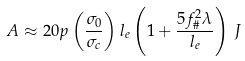Convert formula to latex. <formula><loc_0><loc_0><loc_500><loc_500>A \approx 2 0 p \left ( \frac { \sigma _ { 0 } } { \sigma _ { c } } \right ) l _ { e } \left ( 1 + \frac { 5 f _ { \# } ^ { 2 } \lambda } { l _ { e } } \right ) \, J</formula> 